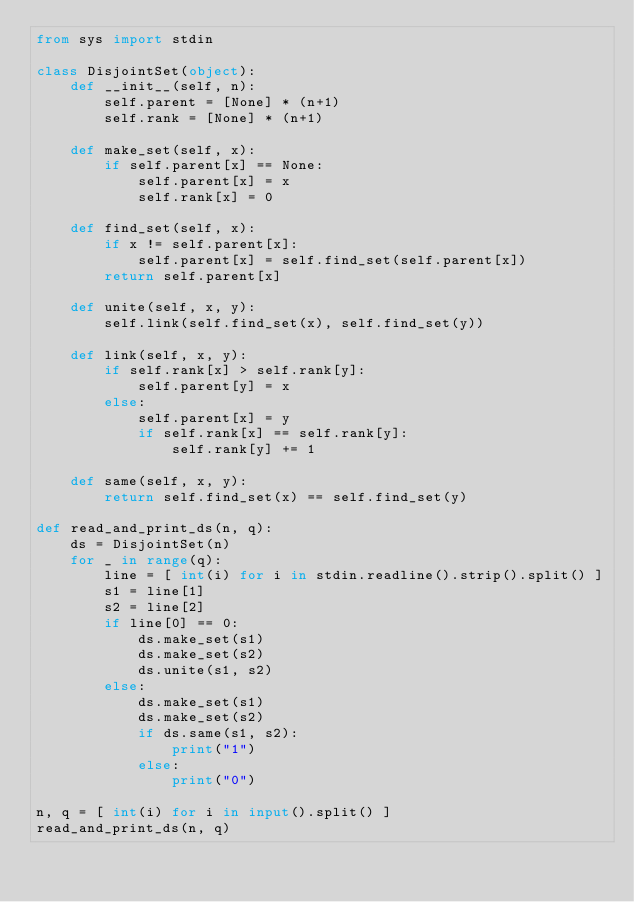Convert code to text. <code><loc_0><loc_0><loc_500><loc_500><_Python_>from sys import stdin

class DisjointSet(object):
    def __init__(self, n):
        self.parent = [None] * (n+1)
        self.rank = [None] * (n+1)

    def make_set(self, x):
        if self.parent[x] == None:
            self.parent[x] = x
            self.rank[x] = 0

    def find_set(self, x):
        if x != self.parent[x]:
            self.parent[x] = self.find_set(self.parent[x])
        return self.parent[x]

    def unite(self, x, y):
        self.link(self.find_set(x), self.find_set(y))

    def link(self, x, y):
        if self.rank[x] > self.rank[y]:
            self.parent[y] = x
        else:
            self.parent[x] = y
            if self.rank[x] == self.rank[y]:
                self.rank[y] += 1

    def same(self, x, y):
        return self.find_set(x) == self.find_set(y)

def read_and_print_ds(n, q):
    ds = DisjointSet(n)
    for _ in range(q):
        line = [ int(i) for i in stdin.readline().strip().split() ]
        s1 = line[1]
        s2 = line[2]
        if line[0] == 0:
            ds.make_set(s1)
            ds.make_set(s2)
            ds.unite(s1, s2)
        else:
            ds.make_set(s1)
            ds.make_set(s2)
            if ds.same(s1, s2):
                print("1")
            else:
                print("0")

n, q = [ int(i) for i in input().split() ]
read_and_print_ds(n, q)
</code> 